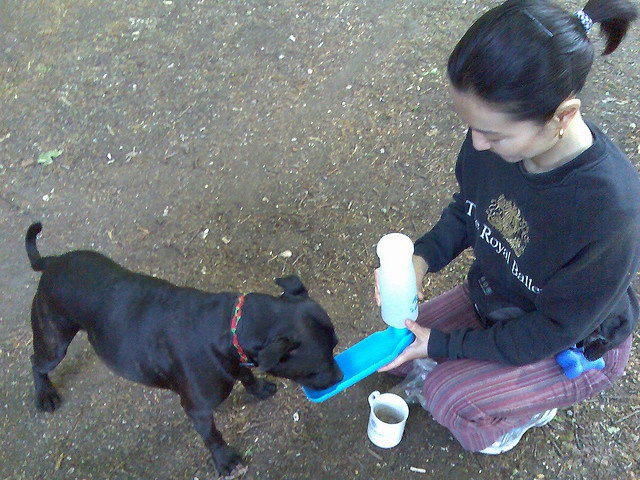Describe the objects in this image and their specific colors. I can see people in darkgray, navy, black, and gray tones, dog in darkgray, black, blue, and gray tones, bottle in darkgray, white, lightblue, and gray tones, and cup in darkgray, white, gray, and lightblue tones in this image. 